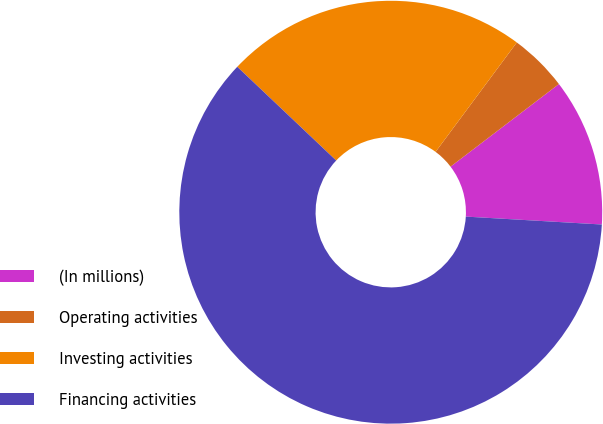Convert chart to OTSL. <chart><loc_0><loc_0><loc_500><loc_500><pie_chart><fcel>(In millions)<fcel>Operating activities<fcel>Investing activities<fcel>Financing activities<nl><fcel>11.29%<fcel>4.47%<fcel>23.09%<fcel>61.14%<nl></chart> 